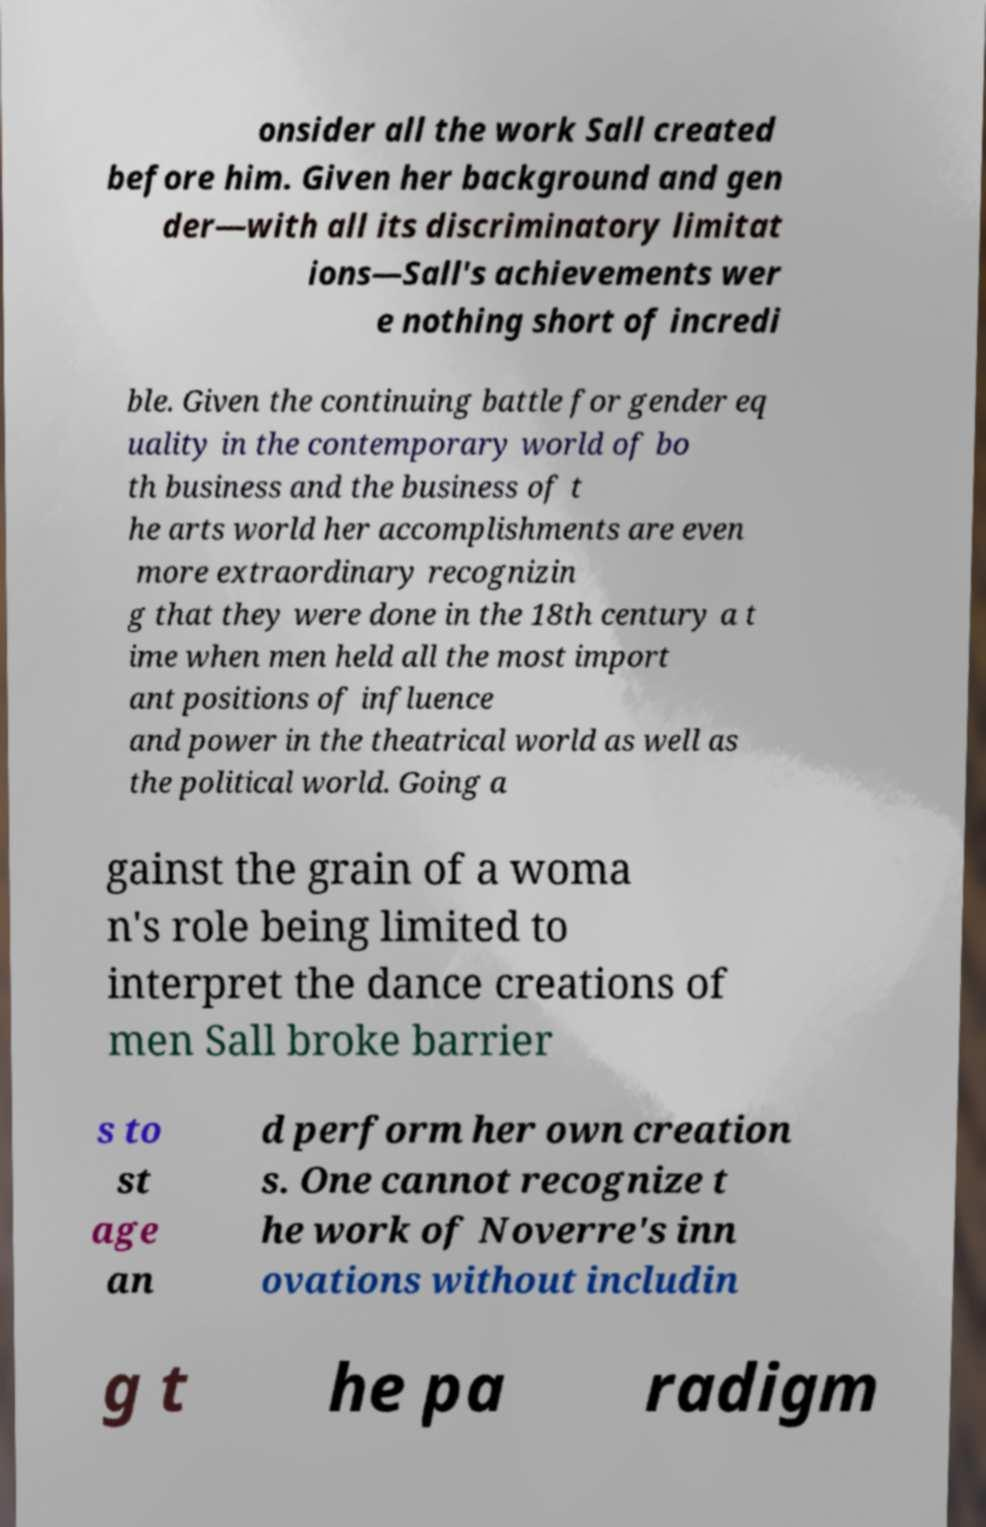For documentation purposes, I need the text within this image transcribed. Could you provide that? onsider all the work Sall created before him. Given her background and gen der—with all its discriminatory limitat ions—Sall's achievements wer e nothing short of incredi ble. Given the continuing battle for gender eq uality in the contemporary world of bo th business and the business of t he arts world her accomplishments are even more extraordinary recognizin g that they were done in the 18th century a t ime when men held all the most import ant positions of influence and power in the theatrical world as well as the political world. Going a gainst the grain of a woma n's role being limited to interpret the dance creations of men Sall broke barrier s to st age an d perform her own creation s. One cannot recognize t he work of Noverre's inn ovations without includin g t he pa radigm 